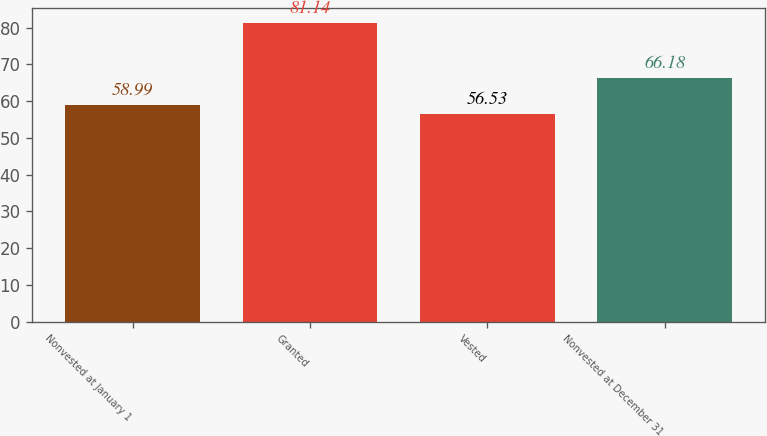Convert chart. <chart><loc_0><loc_0><loc_500><loc_500><bar_chart><fcel>Nonvested at January 1<fcel>Granted<fcel>Vested<fcel>Nonvested at December 31<nl><fcel>58.99<fcel>81.14<fcel>56.53<fcel>66.18<nl></chart> 